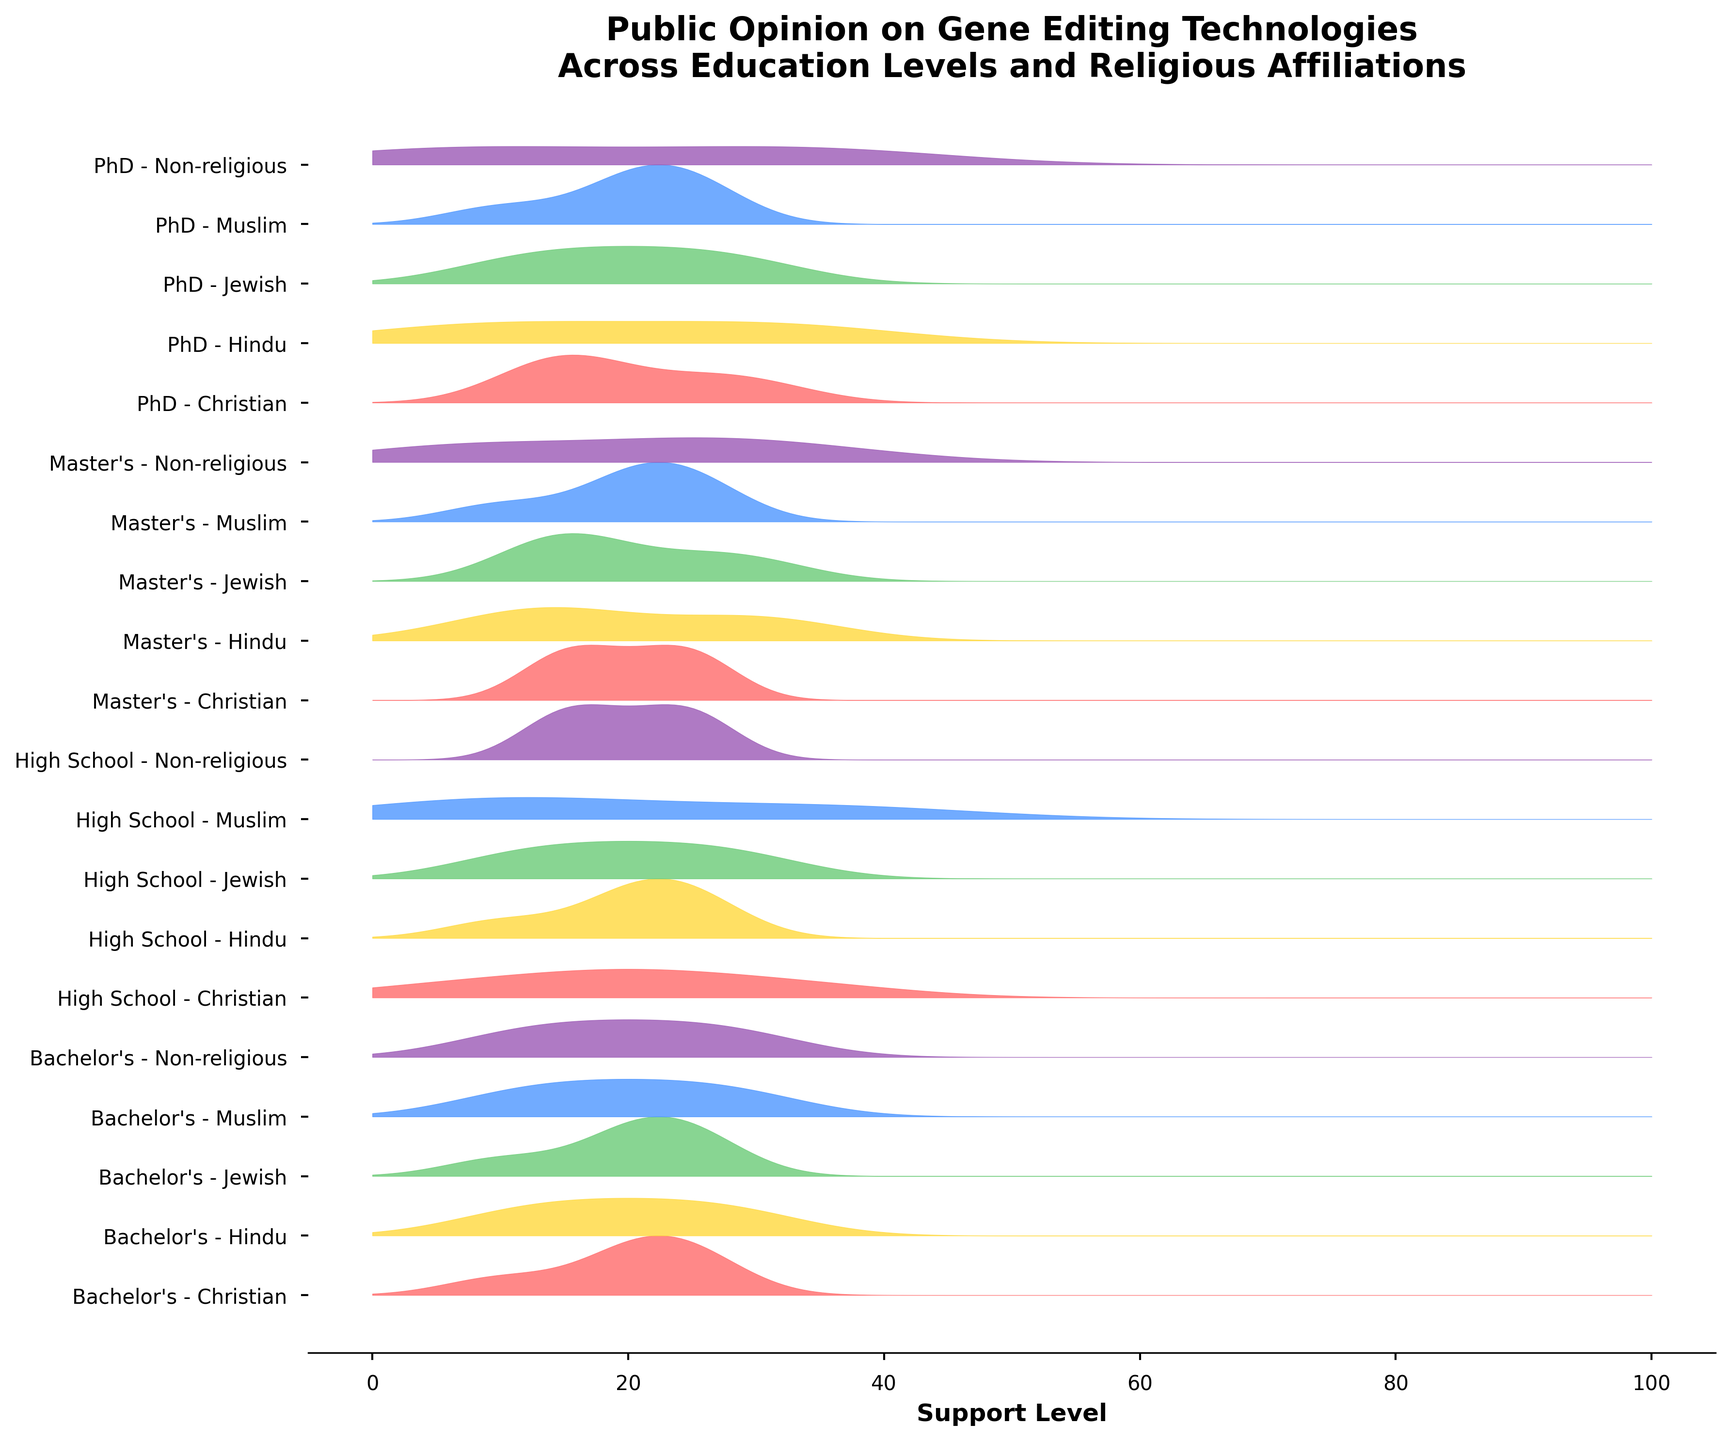What is the title of the figure? The title can be found at the top of the figure and it summarizes the main theme.
Answer: Public Opinion on Gene Editing Technologies Across Education Levels and Religious Affiliations What does the x-axis represent? The x-axis label indicates the variable measured horizontally in the figure. By checking the axis label, we can understand what it measures.
Answer: Support Level Which education level and religious affiliation combination has the highest peak in the "Strongly Support" category? Inspect the visual peaks on the plot. The highest peak corresponding to "Strongly Support" will be the tallest in height.
Answer: PhD, Non-religious What pattern is evident when comparing the support levels between religious and non-religious groups across all education levels? To answer this, observe the density curves of religious groups vs. non-religious groups. Notice any consistent differences in the shape or peaks of the curves.
Answer: Non-religious groups tend to show higher support levels Are there any education levels where Muslim and Christian affiliations have nearly identical opinion distributions? Identify and compare the density curves of Muslim and Christian affiliations across different education levels to see if they have similar shapes and heights.
Answer: High School Which category shows the maximum density for Master's, Hindu affiliation? Look at the density curve for Master's level Hindu affiliation. Identify the spot with the highest vertical height.
Answer: Somewhat Support How does the distribution of opinions vary between a Bachelor's and a PhD level for Jewish affiliation in terms of "Somewhat Oppose"? Compare the density values at the "Somewhat Oppose" support level for Bachelor's and PhD Jewish affiliations to see which has a higher density value.
Answer: Bachelor's level has higher density for "Somewhat Oppose" What is the most common opinion category for Bachelor's, Non-religious individuals? Observe the most prominent peak of the density curve for Bachelor's, Non-religious group to determine the highest density around a specific opinion category.
Answer: Somewhat Support Which religious affiliation shows the greatest variability in opinion at the Master’s education level? Analyze the spread of the density curve for different religious affiliations at the Master’s level. The affiliation with the widest spread shows the greatest variability.
Answer: Non-religious 